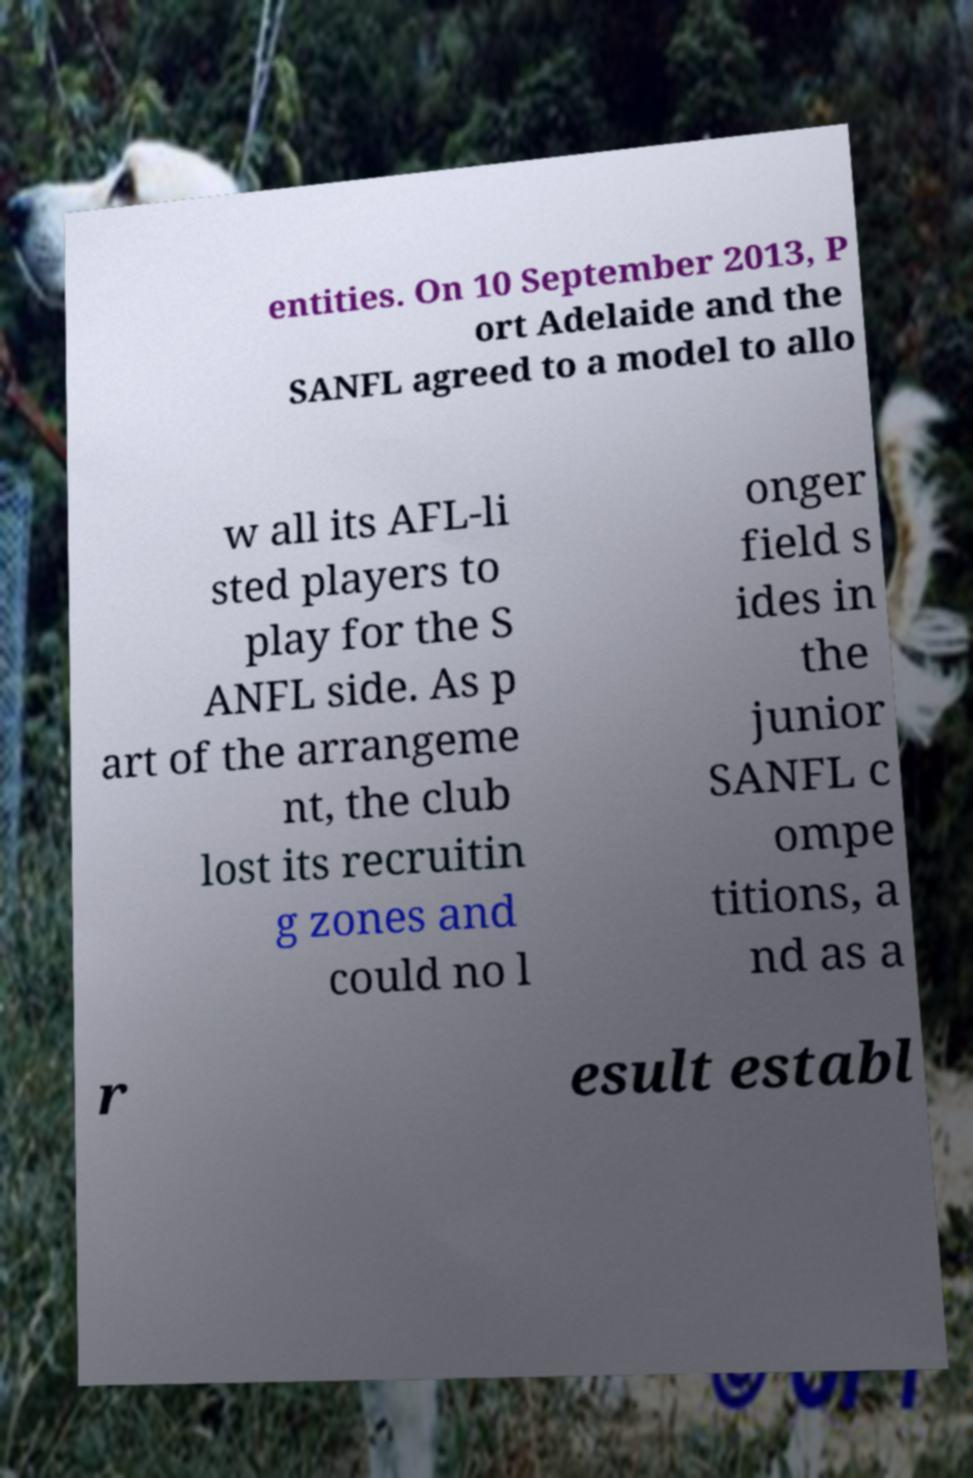There's text embedded in this image that I need extracted. Can you transcribe it verbatim? entities. On 10 September 2013, P ort Adelaide and the SANFL agreed to a model to allo w all its AFL-li sted players to play for the S ANFL side. As p art of the arrangeme nt, the club lost its recruitin g zones and could no l onger field s ides in the junior SANFL c ompe titions, a nd as a r esult establ 